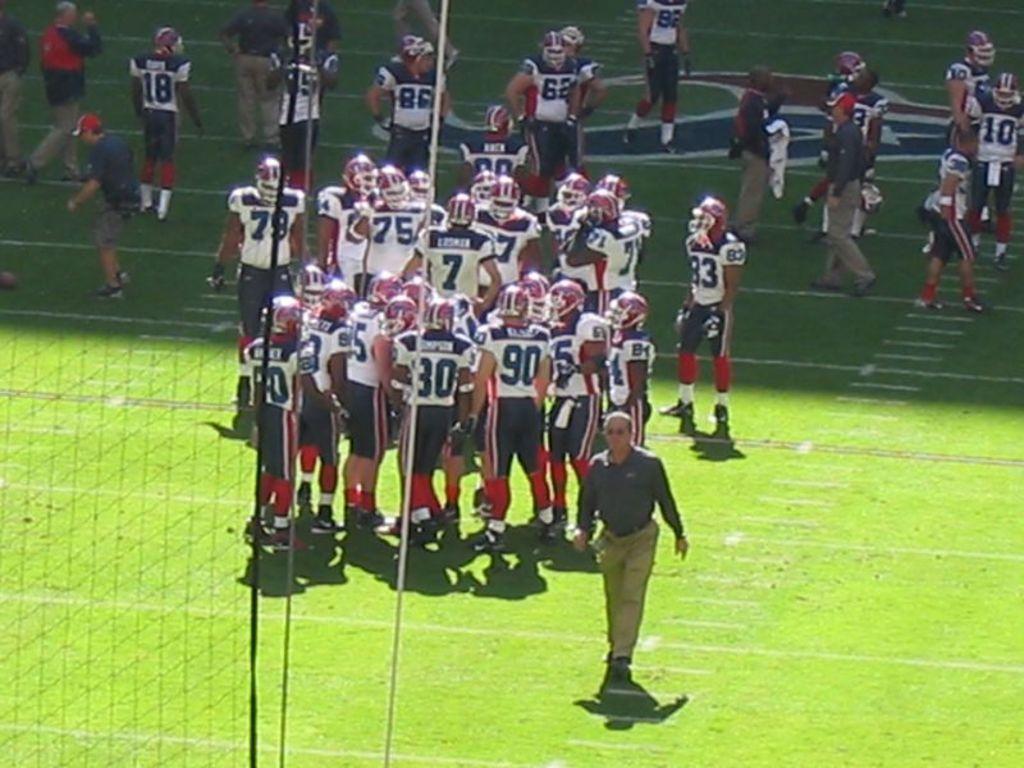Describe this image in one or two sentences. The picture is clicked in a rugby stadium where we observe all the players are in the ground and the manager is walking back to the pavilion. There is a goal post to the left side of the image. 